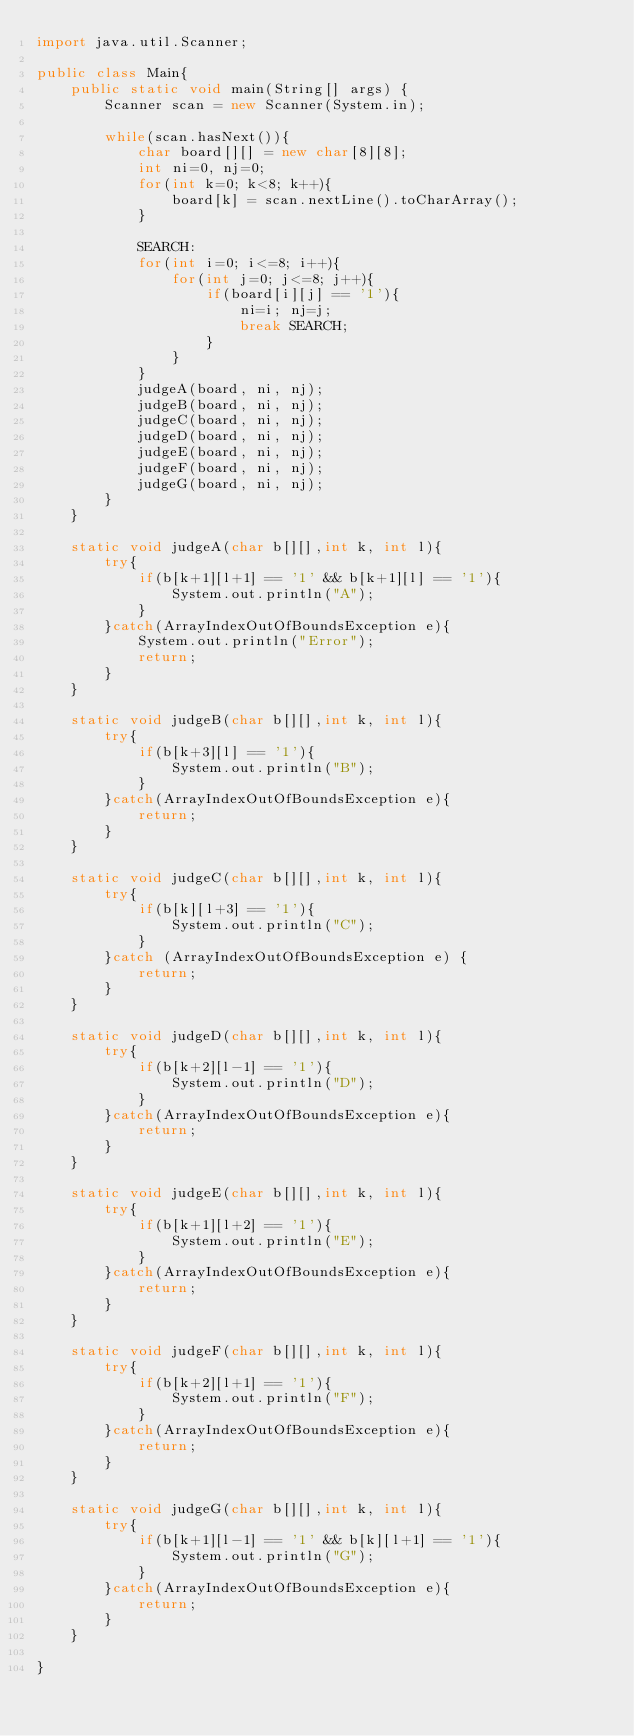Convert code to text. <code><loc_0><loc_0><loc_500><loc_500><_Java_>import java.util.Scanner;

public class Main{
	public static void main(String[] args) {
		Scanner scan = new Scanner(System.in);

		while(scan.hasNext()){
			char board[][] = new char[8][8];
			int ni=0, nj=0;
			for(int k=0; k<8; k++){
				board[k] = scan.nextLine().toCharArray();
			}

			SEARCH:
			for(int i=0; i<=8; i++){
				for(int j=0; j<=8; j++){
					if(board[i][j] == '1'){
						ni=i; nj=j;
						break SEARCH;
					}
				}
			}
			judgeA(board, ni, nj);
			judgeB(board, ni, nj);
			judgeC(board, ni, nj);
			judgeD(board, ni, nj);
			judgeE(board, ni, nj);
			judgeF(board, ni, nj);
			judgeG(board, ni, nj);
		}
	}

	static void judgeA(char b[][],int k, int l){
		try{
			if(b[k+1][l+1] == '1' && b[k+1][l] == '1'){
				System.out.println("A");
			}
		}catch(ArrayIndexOutOfBoundsException e){
			System.out.println("Error");
			return;
		}
	}

	static void judgeB(char b[][],int k, int l){
		try{
			if(b[k+3][l] == '1'){
				System.out.println("B");
			}
		}catch(ArrayIndexOutOfBoundsException e){
			return;
		}
	}

	static void judgeC(char b[][],int k, int l){
		try{
			if(b[k][l+3] == '1'){
				System.out.println("C");
			}
		}catch (ArrayIndexOutOfBoundsException e) {
			return;
		}
	}

	static void judgeD(char b[][],int k, int l){
		try{
			if(b[k+2][l-1] == '1'){
				System.out.println("D");
			}
		}catch(ArrayIndexOutOfBoundsException e){
			return;
		}
	}

	static void judgeE(char b[][],int k, int l){
		try{
			if(b[k+1][l+2] == '1'){
				System.out.println("E");
			}
		}catch(ArrayIndexOutOfBoundsException e){
			return;
		}
	}

	static void judgeF(char b[][],int k, int l){
		try{
			if(b[k+2][l+1] == '1'){
				System.out.println("F");
			}
		}catch(ArrayIndexOutOfBoundsException e){
			return;
		}
	}

	static void judgeG(char b[][],int k, int l){
		try{
			if(b[k+1][l-1] == '1' && b[k][l+1] == '1'){
				System.out.println("G");
			}
		}catch(ArrayIndexOutOfBoundsException e){
			return;
		}
	}

}</code> 